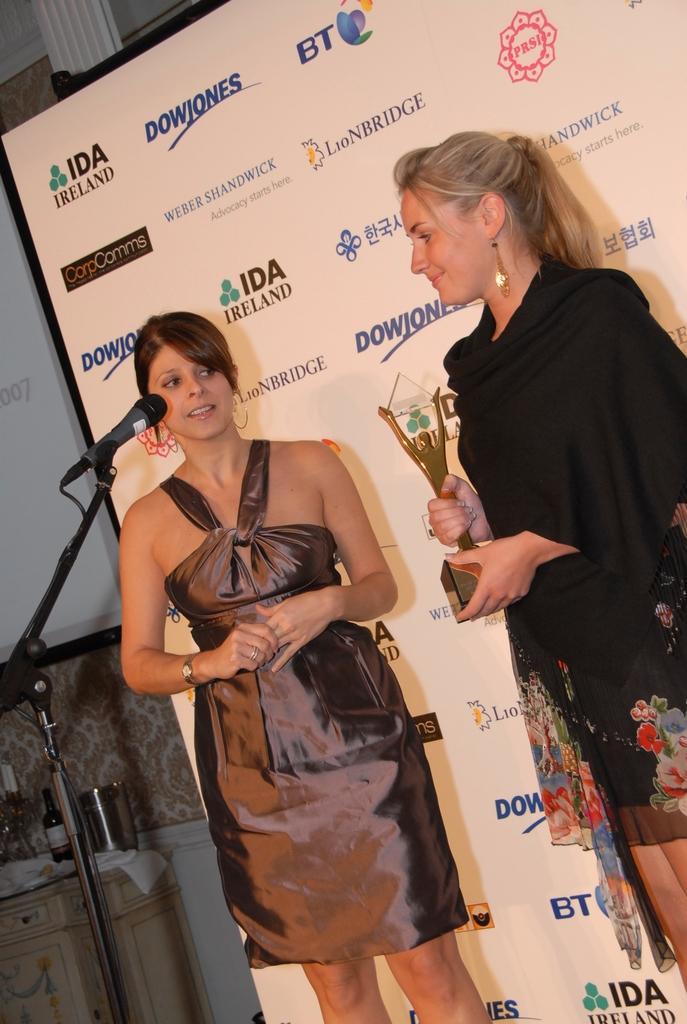Please provide a concise description of this image. In this picture we can observe two women standing. Both of them was smiling. One of the women was wearing brown color dress and the other was wearing black color dress. One of them was holding a prize in their hands. On the left side there is a mic and a stand. In the background there is a white color poster. 